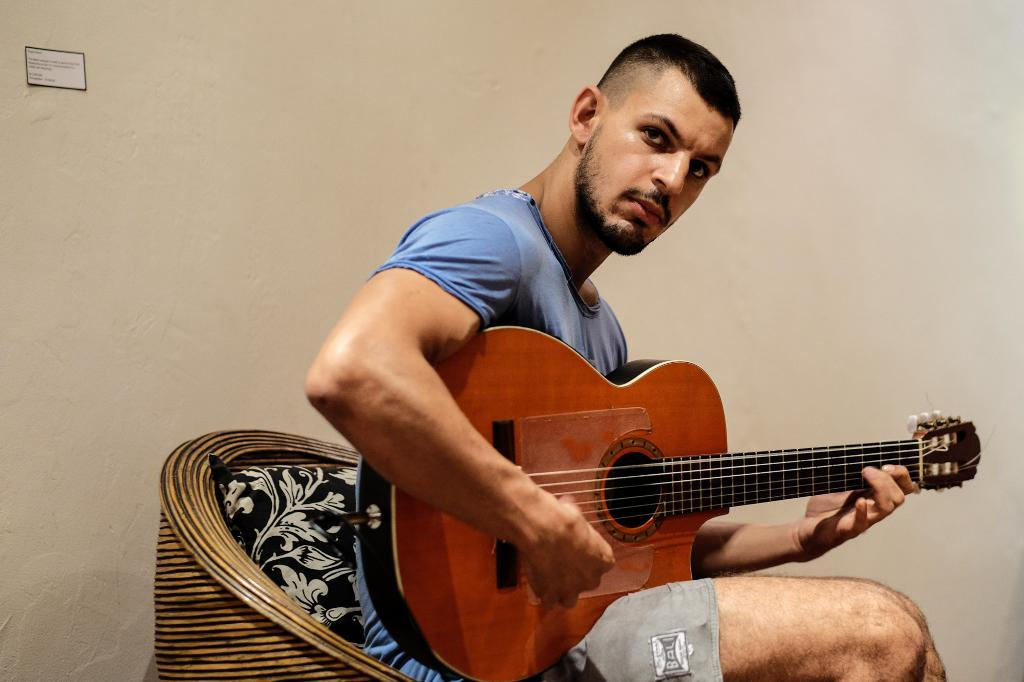Who or what is the main subject in the image? There is a person in the image. What is the person holding in the image? The person is holding a guitar. What is the person's position in the image? The person is sitting on a chair. What color is the background of the image? The background of the image is white. What type of lipstick is the person wearing in the image? There is no lipstick or any indication of makeup on the person in the image. 